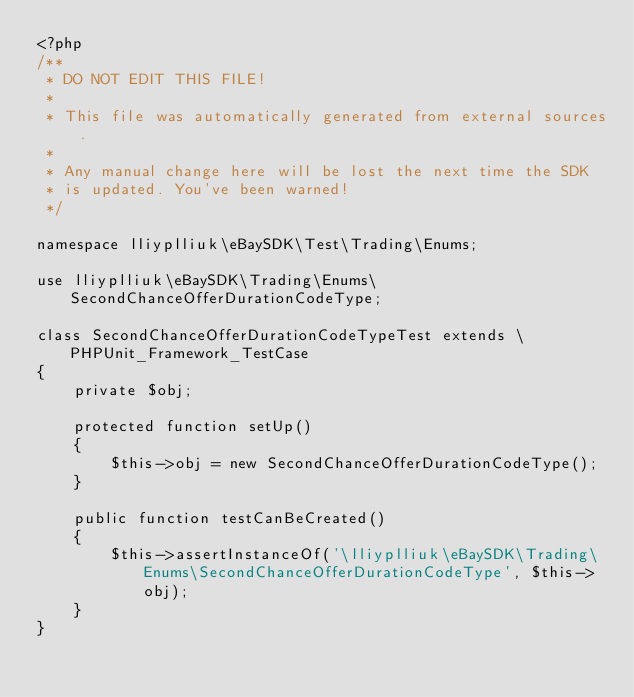<code> <loc_0><loc_0><loc_500><loc_500><_PHP_><?php
/**
 * DO NOT EDIT THIS FILE!
 *
 * This file was automatically generated from external sources.
 *
 * Any manual change here will be lost the next time the SDK
 * is updated. You've been warned!
 */

namespace lliyplliuk\eBaySDK\Test\Trading\Enums;

use lliyplliuk\eBaySDK\Trading\Enums\SecondChanceOfferDurationCodeType;

class SecondChanceOfferDurationCodeTypeTest extends \PHPUnit_Framework_TestCase
{
    private $obj;

    protected function setUp()
    {
        $this->obj = new SecondChanceOfferDurationCodeType();
    }

    public function testCanBeCreated()
    {
        $this->assertInstanceOf('\lliyplliuk\eBaySDK\Trading\Enums\SecondChanceOfferDurationCodeType', $this->obj);
    }
}
</code> 